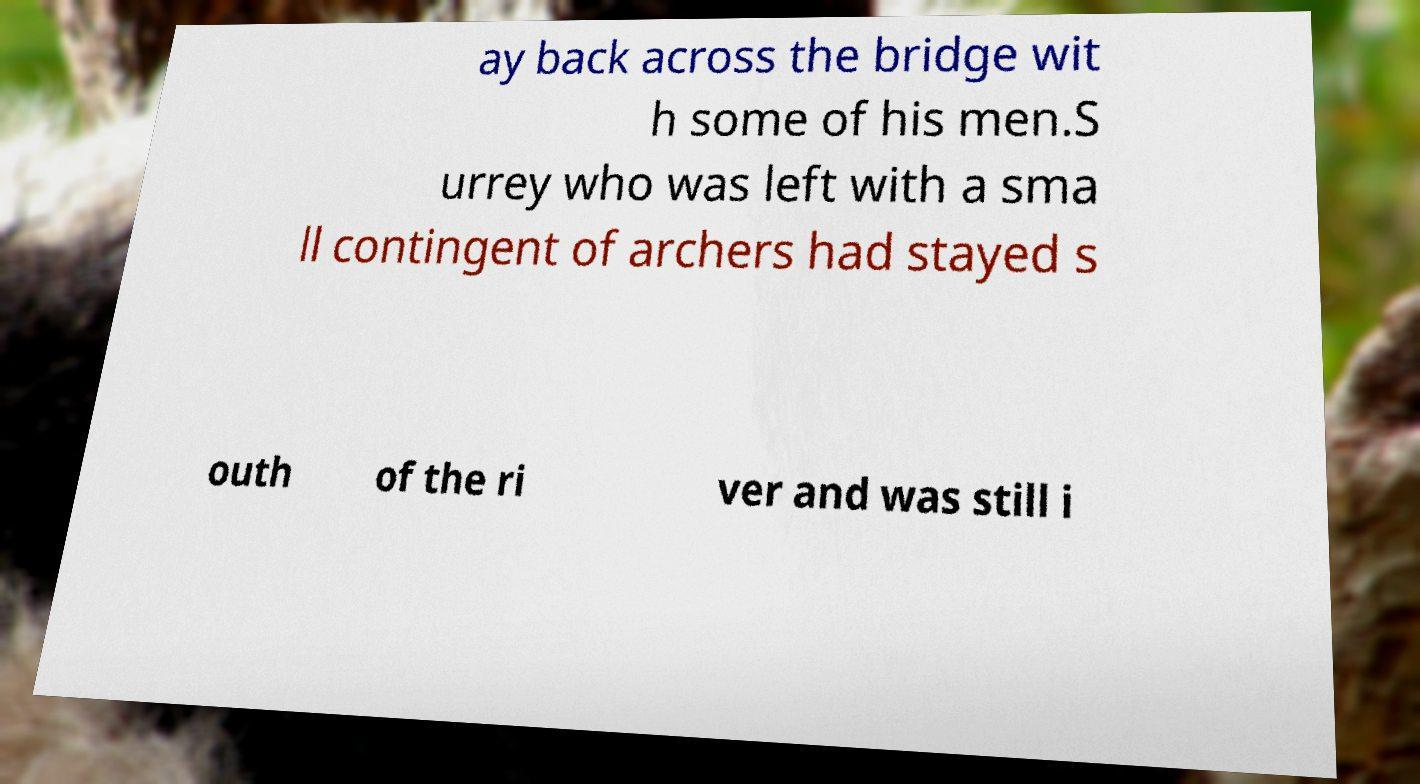What messages or text are displayed in this image? I need them in a readable, typed format. ay back across the bridge wit h some of his men.S urrey who was left with a sma ll contingent of archers had stayed s outh of the ri ver and was still i 